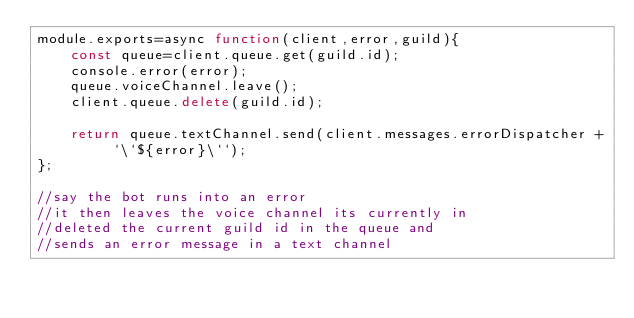Convert code to text. <code><loc_0><loc_0><loc_500><loc_500><_JavaScript_>module.exports=async function(client,error,guild){
    const queue=client.queue.get(guild.id);
    console.error(error);
    queue.voiceChannel.leave();
    client.queue.delete(guild.id);
    
    return queue.textChannel.send(client.messages.errorDispatcher + `\`${error}\``);
};

//say the bot runs into an error
//it then leaves the voice channel its currently in
//deleted the current guild id in the queue and 
//sends an error message in a text channel</code> 